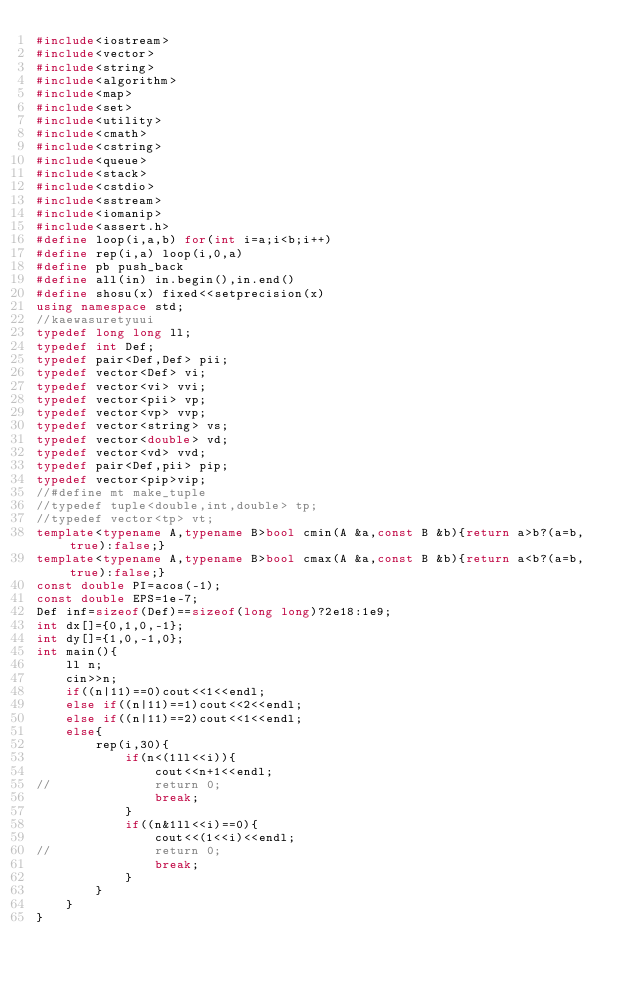<code> <loc_0><loc_0><loc_500><loc_500><_C++_>#include<iostream>
#include<vector>
#include<string>
#include<algorithm>	
#include<map>
#include<set>
#include<utility>
#include<cmath>
#include<cstring>
#include<queue>
#include<stack>
#include<cstdio>
#include<sstream>
#include<iomanip>
#include<assert.h>
#define loop(i,a,b) for(int i=a;i<b;i++) 
#define rep(i,a) loop(i,0,a)
#define pb push_back
#define all(in) in.begin(),in.end()
#define shosu(x) fixed<<setprecision(x)
using namespace std;
//kaewasuretyuui
typedef long long ll;
typedef int Def;
typedef pair<Def,Def> pii;
typedef vector<Def> vi;
typedef vector<vi> vvi;
typedef vector<pii> vp;
typedef vector<vp> vvp;
typedef vector<string> vs;
typedef vector<double> vd;
typedef vector<vd> vvd;
typedef pair<Def,pii> pip;
typedef vector<pip>vip;
//#define mt make_tuple
//typedef tuple<double,int,double> tp;
//typedef vector<tp> vt;
template<typename A,typename B>bool cmin(A &a,const B &b){return a>b?(a=b,true):false;}
template<typename A,typename B>bool cmax(A &a,const B &b){return a<b?(a=b,true):false;}
const double PI=acos(-1);
const double EPS=1e-7;
Def inf=sizeof(Def)==sizeof(long long)?2e18:1e9;
int dx[]={0,1,0,-1};
int dy[]={1,0,-1,0};
int main(){
	ll n;
	cin>>n;
	if((n|11)==0)cout<<1<<endl;
	else if((n|11)==1)cout<<2<<endl;
	else if((n|11)==2)cout<<1<<endl;
	else{
		rep(i,30){
			if(n<(1ll<<i)){
				cout<<n+1<<endl;
//				return 0;
				break;
			}
			if((n&1ll<<i)==0){
				cout<<(1<<i)<<endl;
//				return 0;
				break;
			}
		}
	}
}</code> 